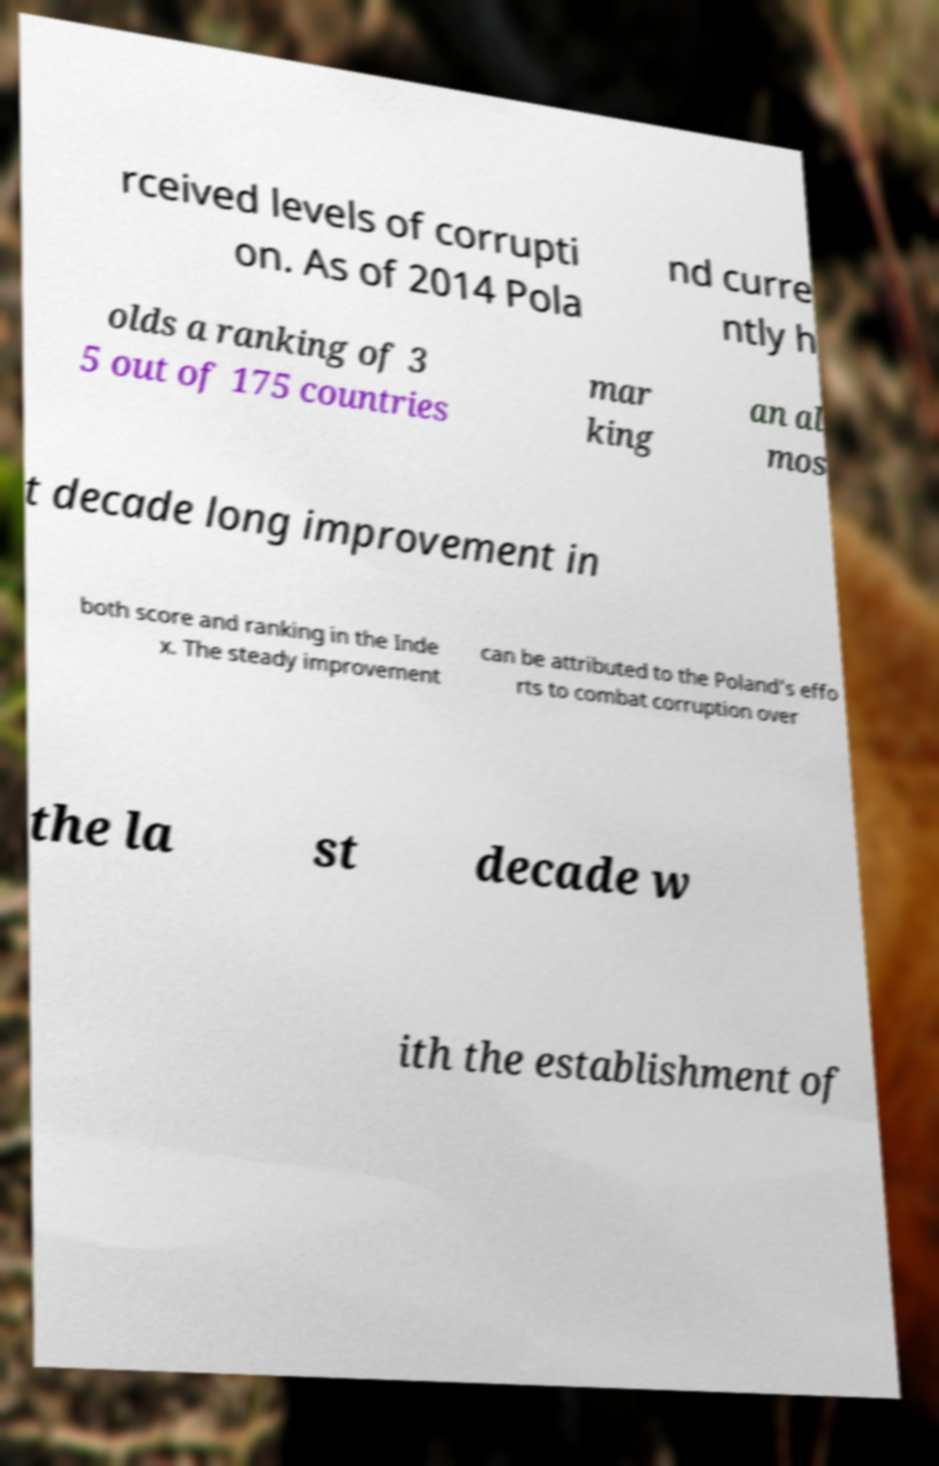Can you accurately transcribe the text from the provided image for me? rceived levels of corrupti on. As of 2014 Pola nd curre ntly h olds a ranking of 3 5 out of 175 countries mar king an al mos t decade long improvement in both score and ranking in the Inde x. The steady improvement can be attributed to the Poland's effo rts to combat corruption over the la st decade w ith the establishment of 